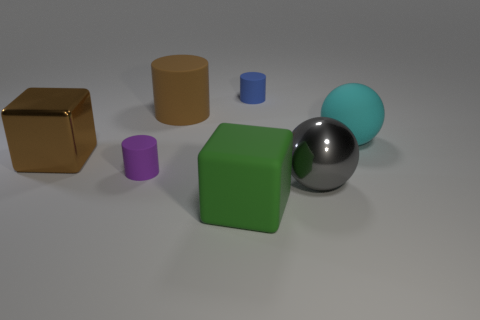Add 2 green matte cylinders. How many objects exist? 9 Subtract all cylinders. How many objects are left? 4 Add 6 small objects. How many small objects are left? 8 Add 7 metal cubes. How many metal cubes exist? 8 Subtract 0 red cylinders. How many objects are left? 7 Subtract all tiny yellow matte spheres. Subtract all tiny blue things. How many objects are left? 6 